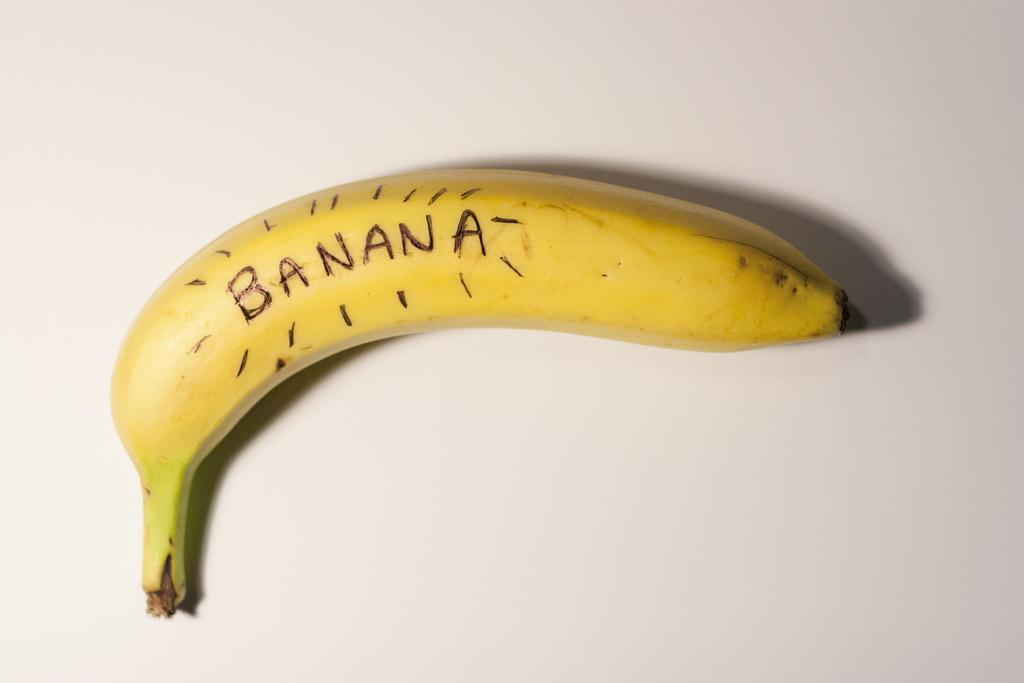<image>
Give a short and clear explanation of the subsequent image. a banana with the word banana on it 